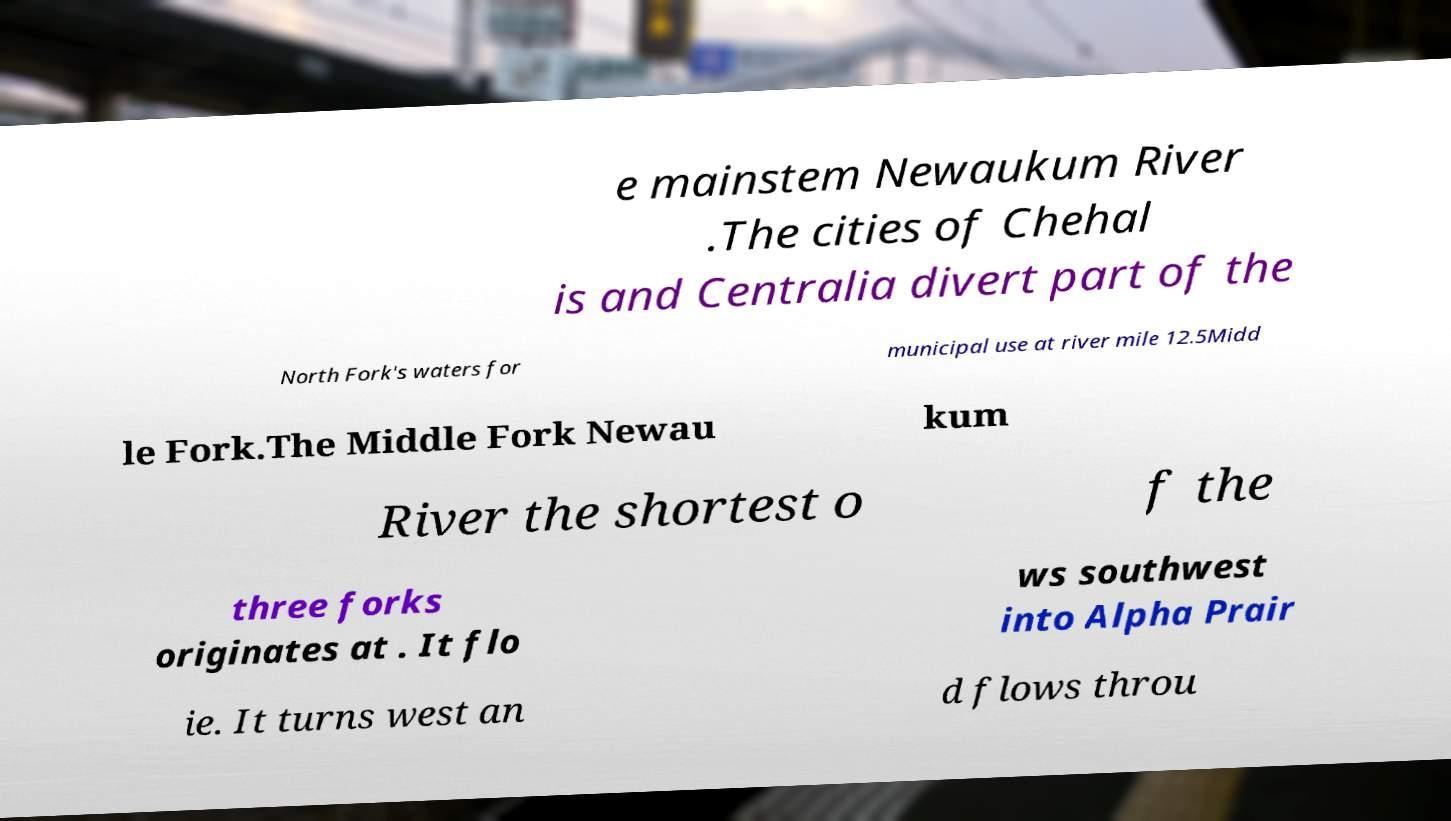Could you extract and type out the text from this image? e mainstem Newaukum River .The cities of Chehal is and Centralia divert part of the North Fork's waters for municipal use at river mile 12.5Midd le Fork.The Middle Fork Newau kum River the shortest o f the three forks originates at . It flo ws southwest into Alpha Prair ie. It turns west an d flows throu 